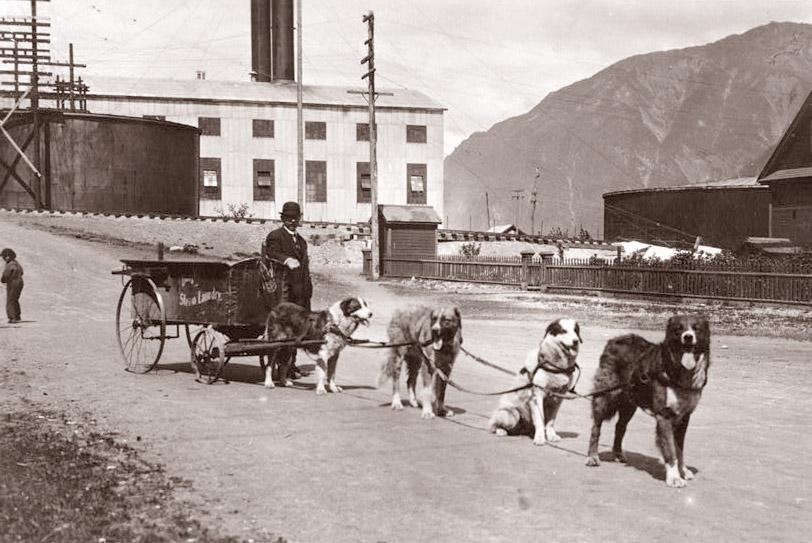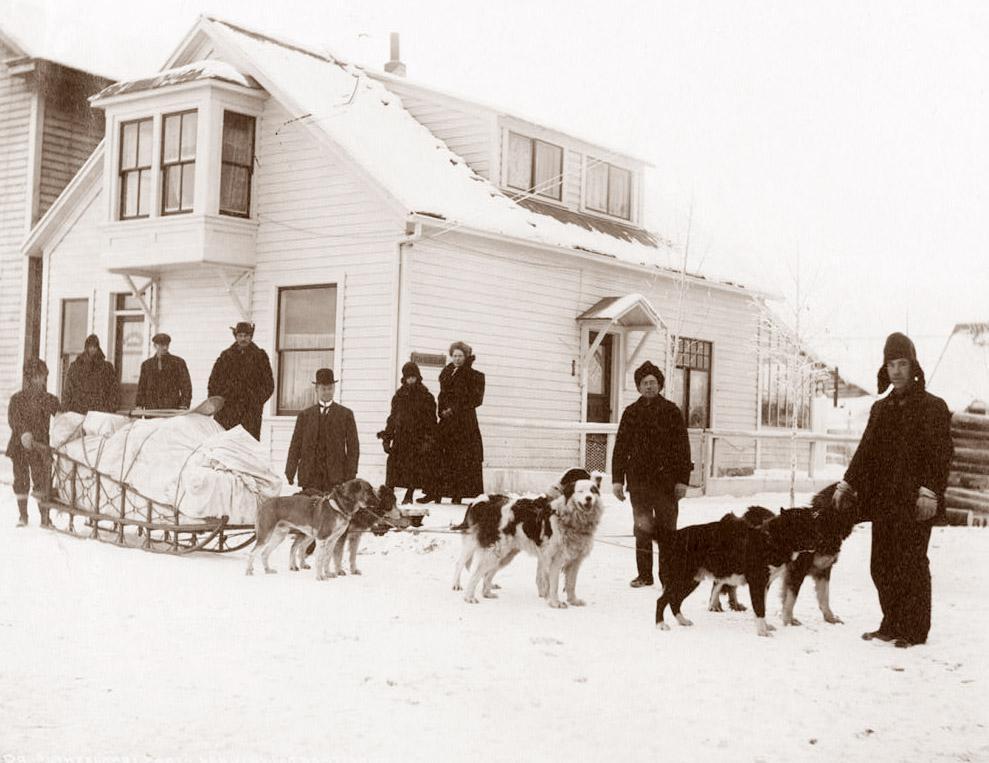The first image is the image on the left, the second image is the image on the right. For the images displayed, is the sentence "There are fewer than four people in total." factually correct? Answer yes or no. No. The first image is the image on the left, the second image is the image on the right. For the images displayed, is the sentence "Each image shows a dog team with a standing sled driver at the back in a snow-covered field with no business buildings in view." factually correct? Answer yes or no. No. 